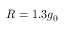Convert formula to latex. <formula><loc_0><loc_0><loc_500><loc_500>R = 1 . 3 g _ { 0 }</formula> 